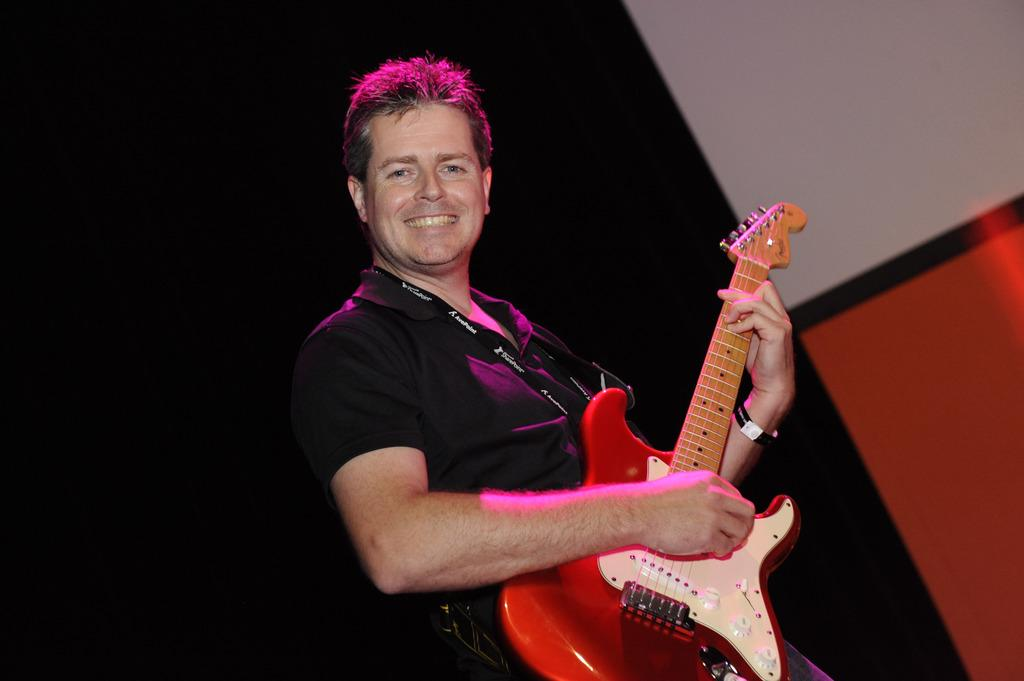What is the main subject of the image? There is a man in the image. What is the man doing in the image? The man is standing in the image. What object is the man holding in the image? The man is holding a guitar in the image. What can be seen in the background of the image? There is a wall in the background of the image. What is the man's temper like in the image? There is no information about the man's temper in the image. 